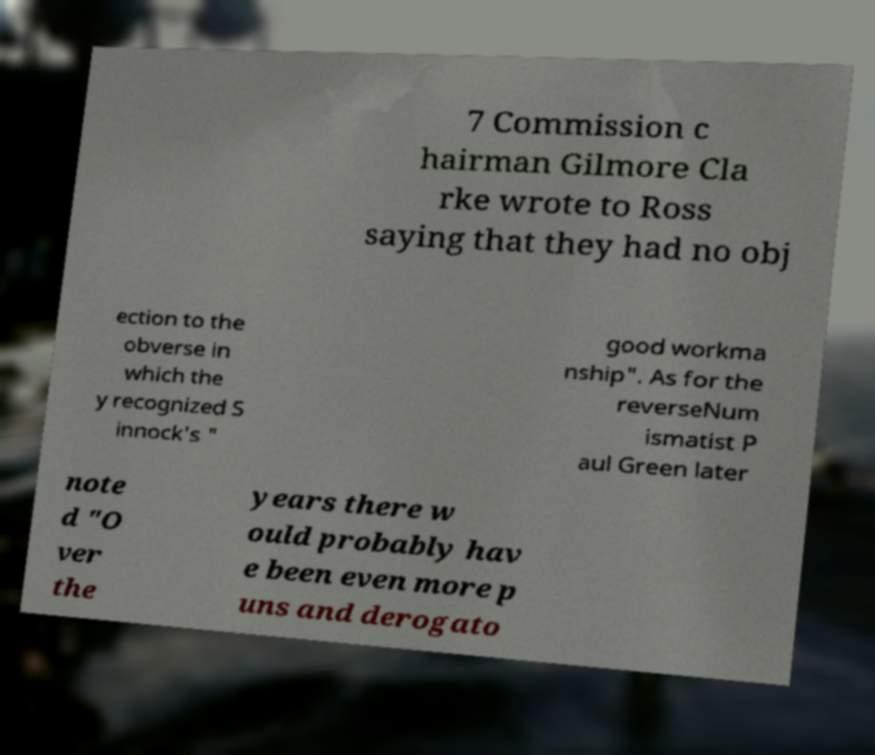Please read and relay the text visible in this image. What does it say? 7 Commission c hairman Gilmore Cla rke wrote to Ross saying that they had no obj ection to the obverse in which the y recognized S innock's " good workma nship". As for the reverseNum ismatist P aul Green later note d "O ver the years there w ould probably hav e been even more p uns and derogato 